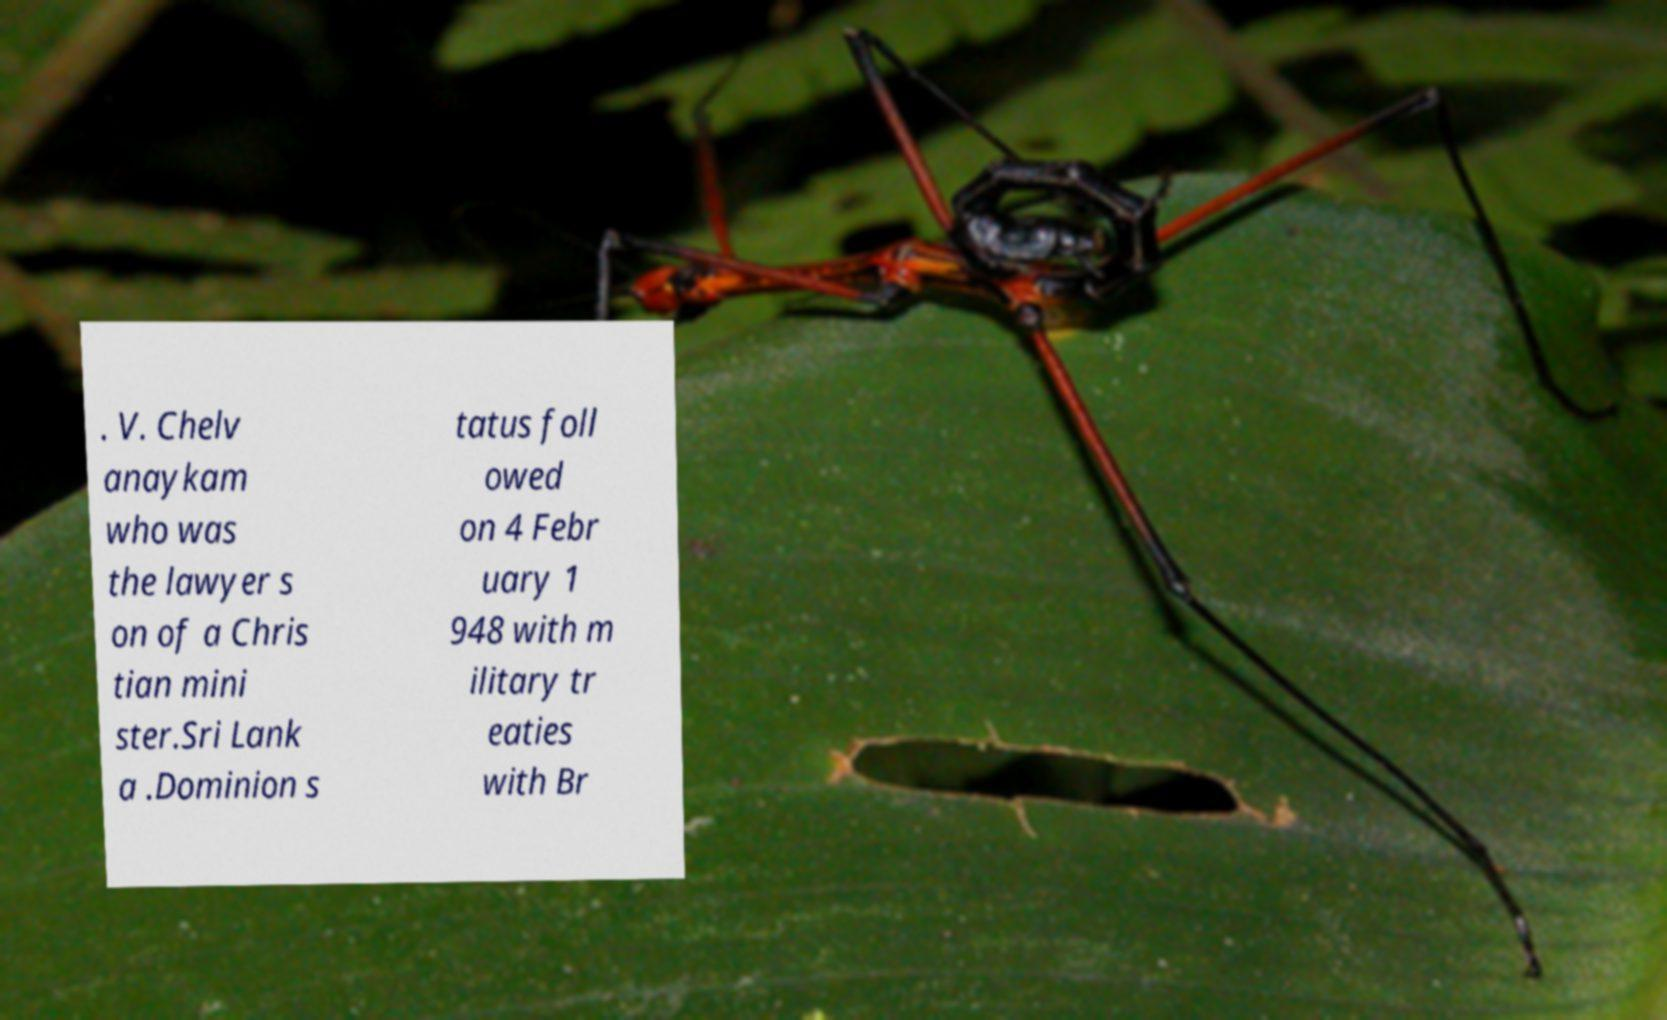Please read and relay the text visible in this image. What does it say? . V. Chelv anaykam who was the lawyer s on of a Chris tian mini ster.Sri Lank a .Dominion s tatus foll owed on 4 Febr uary 1 948 with m ilitary tr eaties with Br 